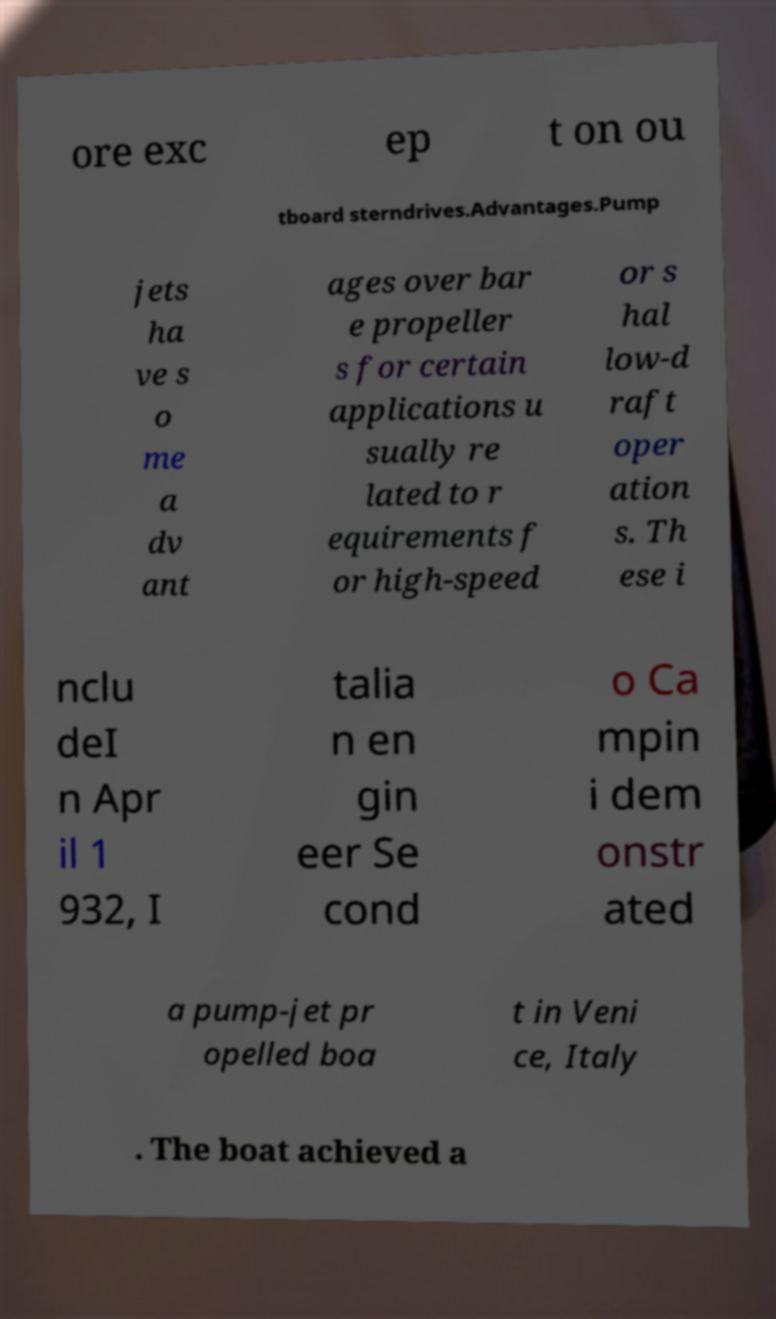Please identify and transcribe the text found in this image. ore exc ep t on ou tboard sterndrives.Advantages.Pump jets ha ve s o me a dv ant ages over bar e propeller s for certain applications u sually re lated to r equirements f or high-speed or s hal low-d raft oper ation s. Th ese i nclu deI n Apr il 1 932, I talia n en gin eer Se cond o Ca mpin i dem onstr ated a pump-jet pr opelled boa t in Veni ce, Italy . The boat achieved a 